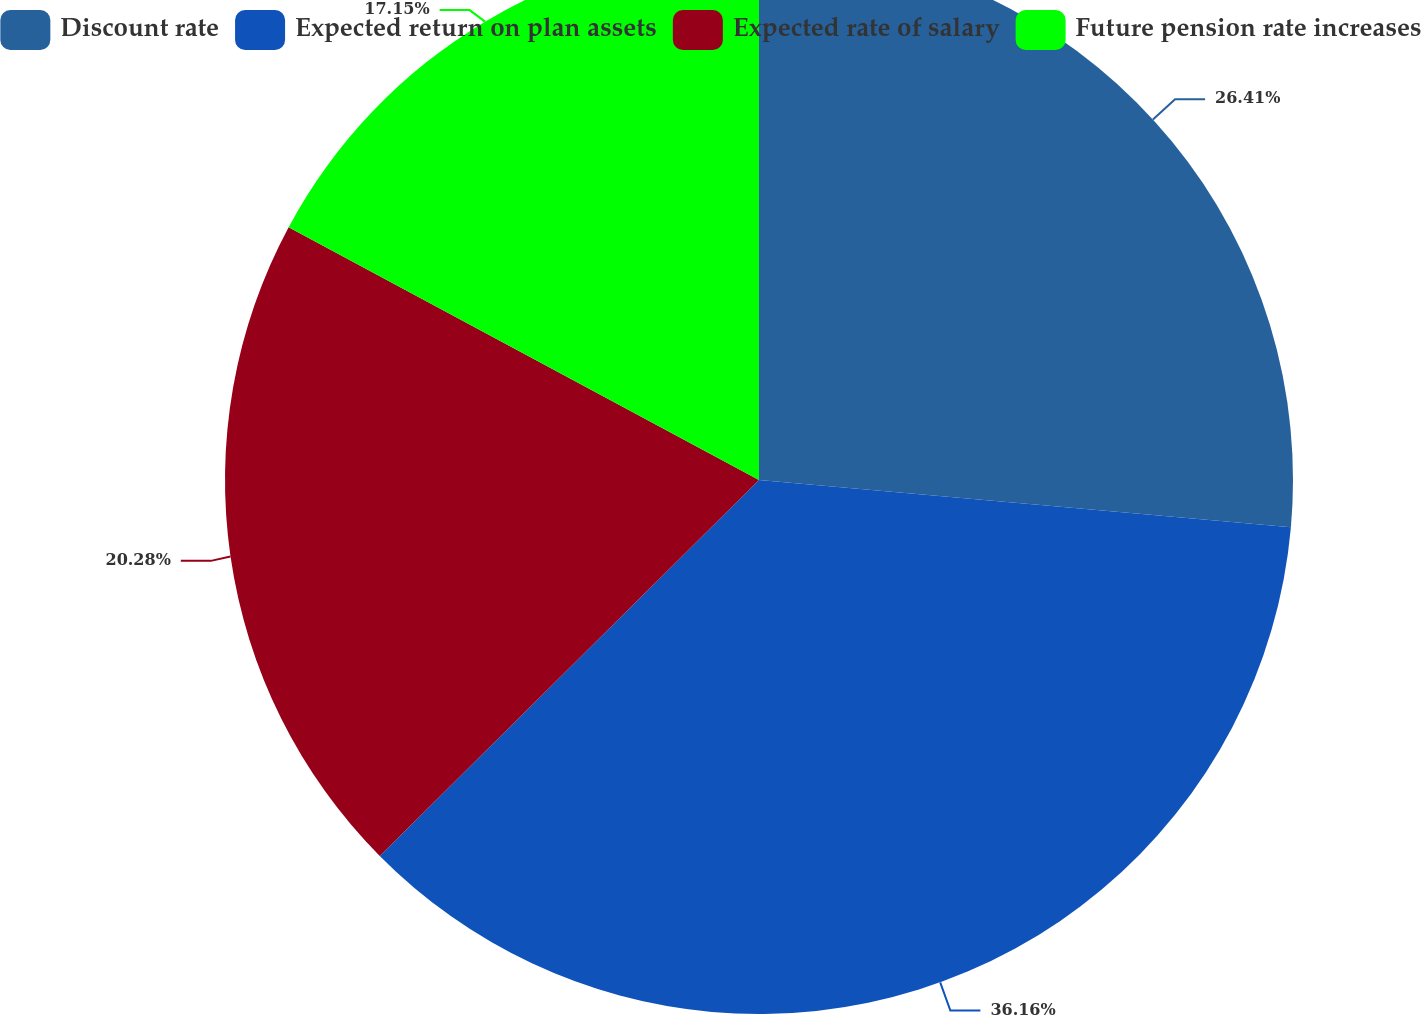Convert chart to OTSL. <chart><loc_0><loc_0><loc_500><loc_500><pie_chart><fcel>Discount rate<fcel>Expected return on plan assets<fcel>Expected rate of salary<fcel>Future pension rate increases<nl><fcel>26.41%<fcel>36.16%<fcel>20.28%<fcel>17.15%<nl></chart> 